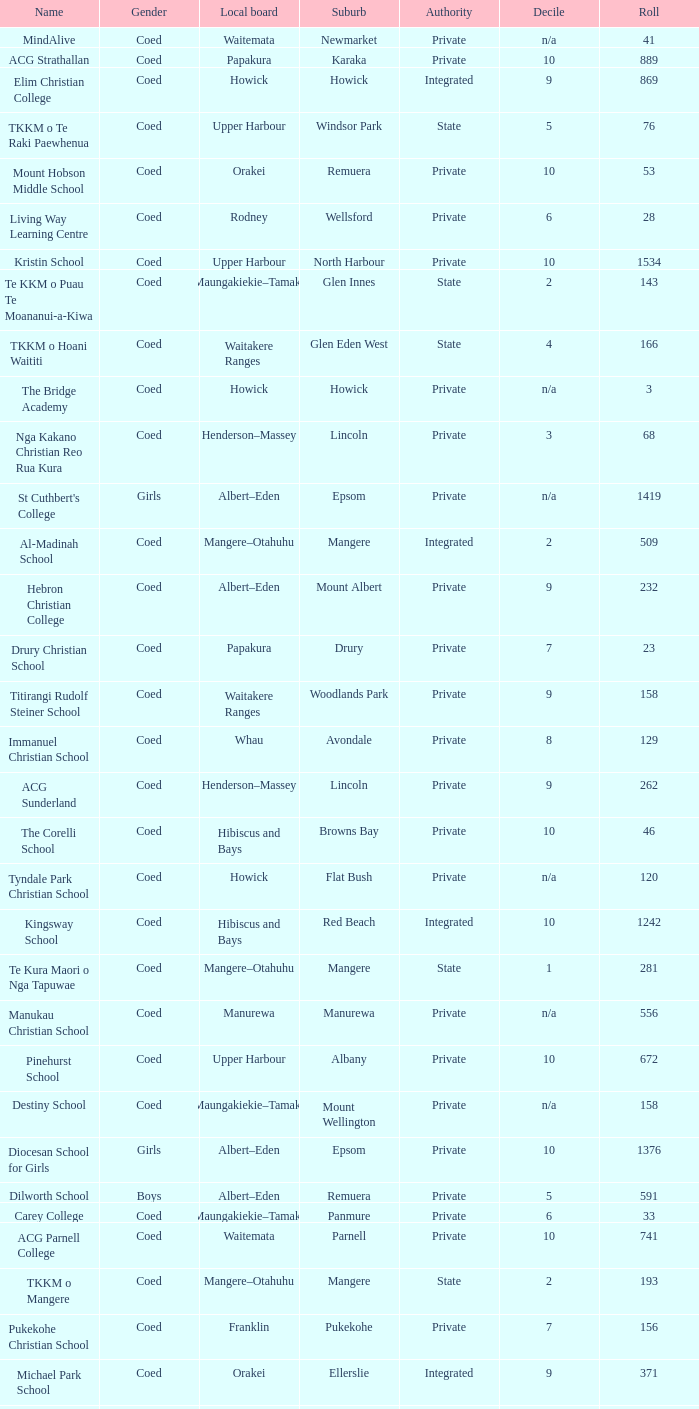What gender has a local board of albert–eden with a roll of more than 232 and Decile of 5? Boys. 